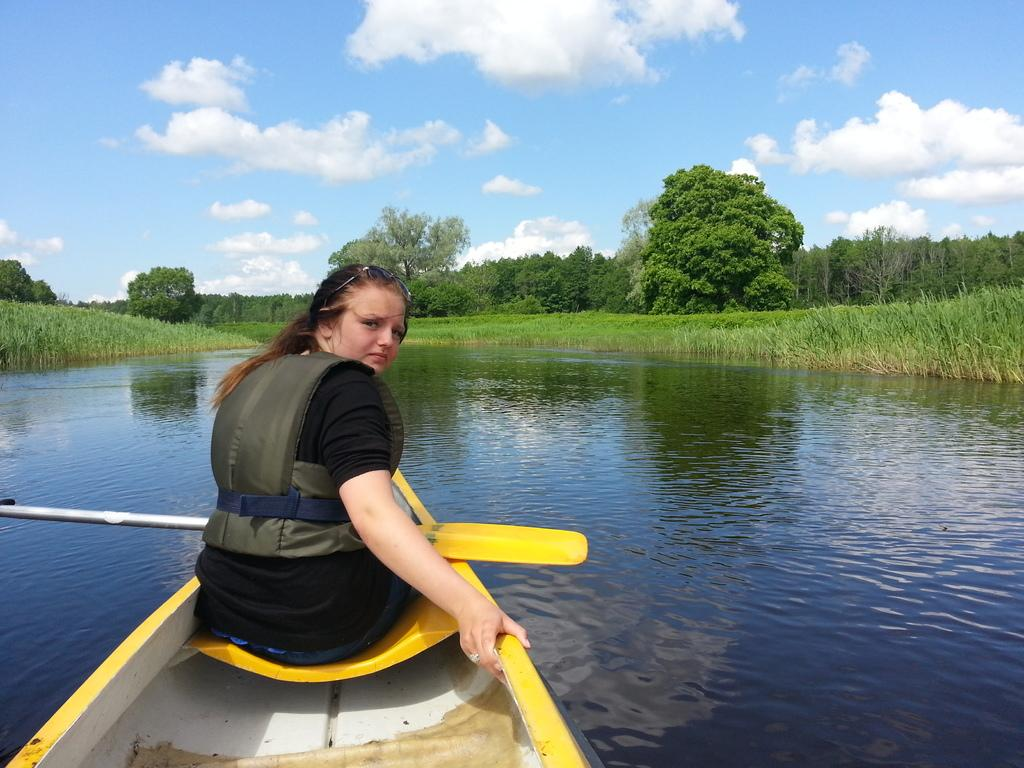What is the person in the image doing? The person is sitting in a boat in the image. Where is the boat located? The boat is in the water. What can be seen in the image besides the boat and person? There are plants and trees visible in the image. What is visible in the sky in the image? There are clouds in the sky in the image. How many dimes are visible on the water's surface in the image? There are no dimes visible on the water's surface in the image. Is there a volleyball game taking place in the image? There is no volleyball game present in the image. 